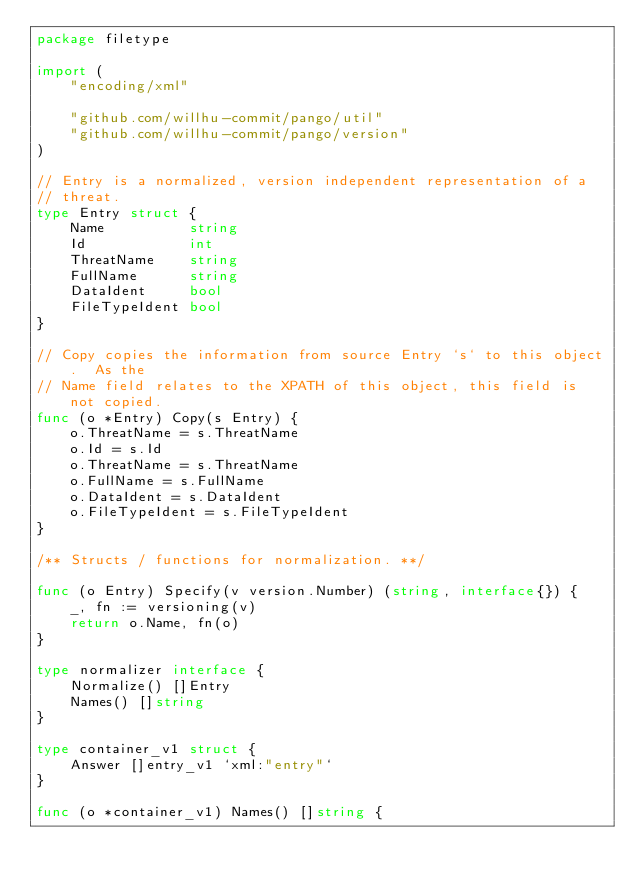Convert code to text. <code><loc_0><loc_0><loc_500><loc_500><_Go_>package filetype

import (
	"encoding/xml"

	"github.com/willhu-commit/pango/util"
	"github.com/willhu-commit/pango/version"
)

// Entry is a normalized, version independent representation of a
// threat.
type Entry struct {
	Name          string
	Id            int
	ThreatName    string
	FullName      string
	DataIdent     bool
	FileTypeIdent bool
}

// Copy copies the information from source Entry `s` to this object.  As the
// Name field relates to the XPATH of this object, this field is not copied.
func (o *Entry) Copy(s Entry) {
	o.ThreatName = s.ThreatName
	o.Id = s.Id
	o.ThreatName = s.ThreatName
	o.FullName = s.FullName
	o.DataIdent = s.DataIdent
	o.FileTypeIdent = s.FileTypeIdent
}

/** Structs / functions for normalization. **/

func (o Entry) Specify(v version.Number) (string, interface{}) {
	_, fn := versioning(v)
	return o.Name, fn(o)
}

type normalizer interface {
	Normalize() []Entry
	Names() []string
}

type container_v1 struct {
	Answer []entry_v1 `xml:"entry"`
}

func (o *container_v1) Names() []string {</code> 